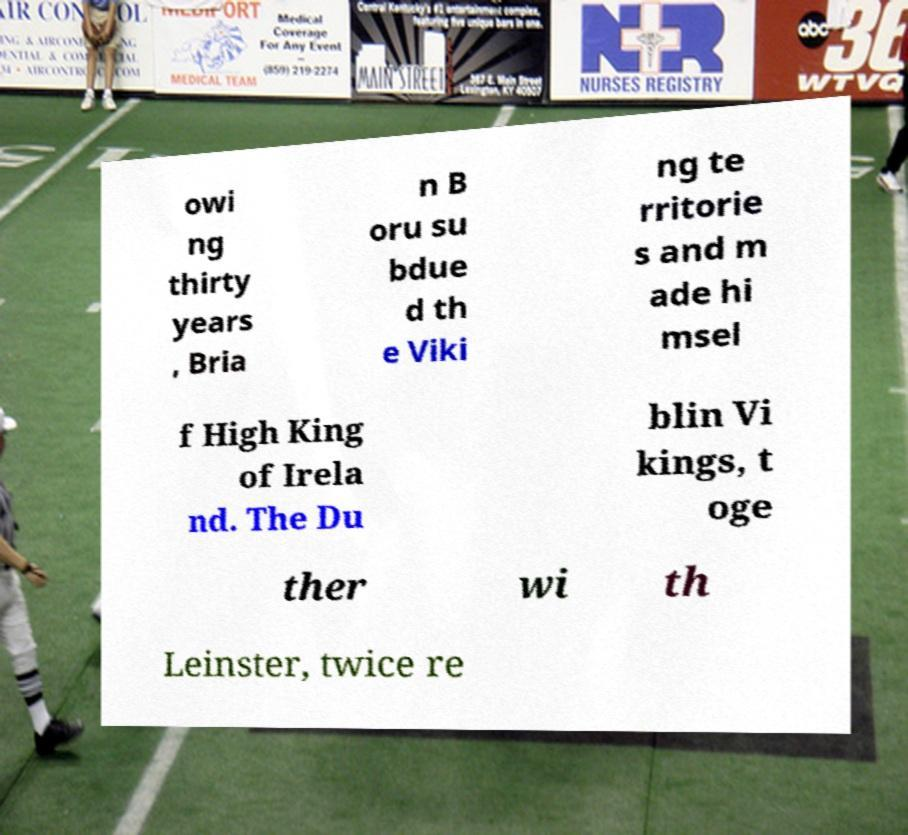Can you read and provide the text displayed in the image?This photo seems to have some interesting text. Can you extract and type it out for me? owi ng thirty years , Bria n B oru su bdue d th e Viki ng te rritorie s and m ade hi msel f High King of Irela nd. The Du blin Vi kings, t oge ther wi th Leinster, twice re 